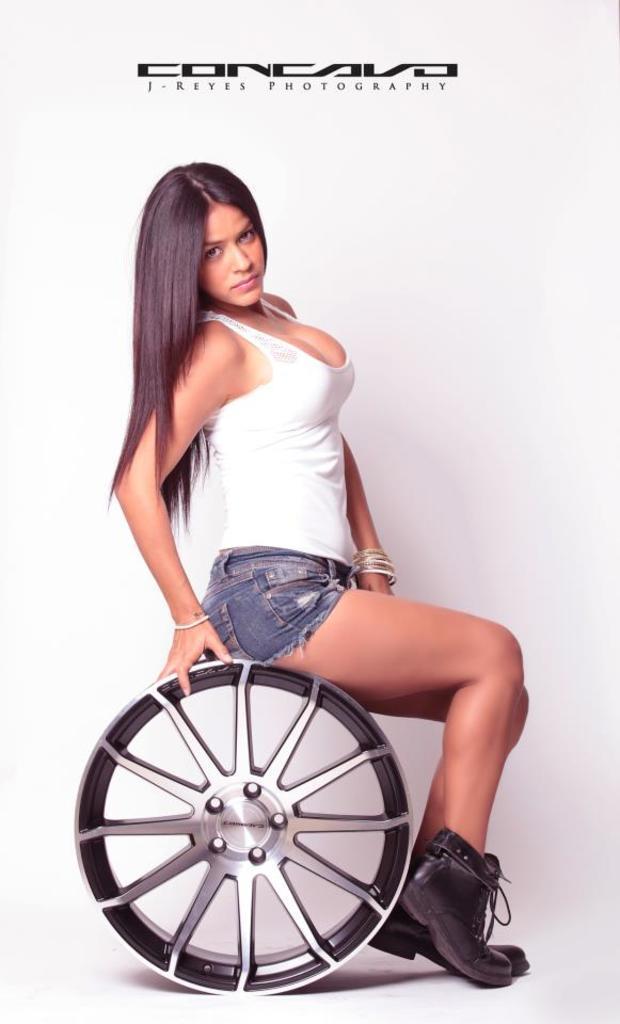Describe this image in one or two sentences. In this image a woman is sitting on a wheel facing towards the right side and giving pose for the picture. The background is in white color. At the top of the image there is some edited text. 